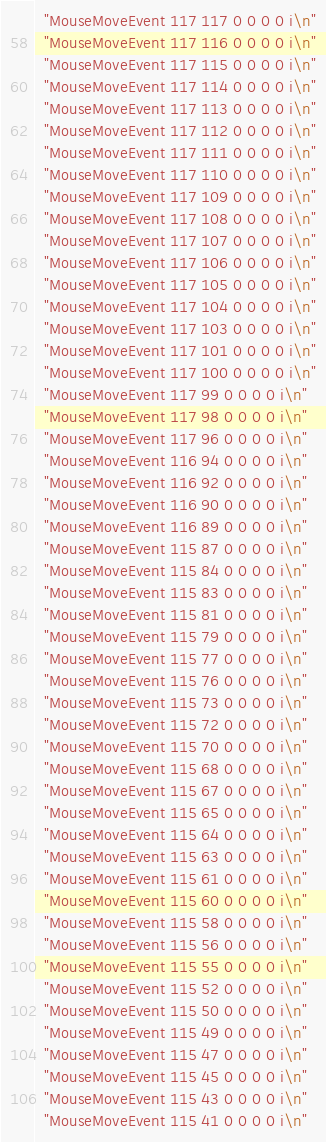<code> <loc_0><loc_0><loc_500><loc_500><_C++_>  "MouseMoveEvent 117 117 0 0 0 0 i\n"
  "MouseMoveEvent 117 116 0 0 0 0 i\n"
  "MouseMoveEvent 117 115 0 0 0 0 i\n"
  "MouseMoveEvent 117 114 0 0 0 0 i\n"
  "MouseMoveEvent 117 113 0 0 0 0 i\n"
  "MouseMoveEvent 117 112 0 0 0 0 i\n"
  "MouseMoveEvent 117 111 0 0 0 0 i\n"
  "MouseMoveEvent 117 110 0 0 0 0 i\n"
  "MouseMoveEvent 117 109 0 0 0 0 i\n"
  "MouseMoveEvent 117 108 0 0 0 0 i\n"
  "MouseMoveEvent 117 107 0 0 0 0 i\n"
  "MouseMoveEvent 117 106 0 0 0 0 i\n"
  "MouseMoveEvent 117 105 0 0 0 0 i\n"
  "MouseMoveEvent 117 104 0 0 0 0 i\n"
  "MouseMoveEvent 117 103 0 0 0 0 i\n"
  "MouseMoveEvent 117 101 0 0 0 0 i\n"
  "MouseMoveEvent 117 100 0 0 0 0 i\n"
  "MouseMoveEvent 117 99 0 0 0 0 i\n"
  "MouseMoveEvent 117 98 0 0 0 0 i\n"
  "MouseMoveEvent 117 96 0 0 0 0 i\n"
  "MouseMoveEvent 116 94 0 0 0 0 i\n"
  "MouseMoveEvent 116 92 0 0 0 0 i\n"
  "MouseMoveEvent 116 90 0 0 0 0 i\n"
  "MouseMoveEvent 116 89 0 0 0 0 i\n"
  "MouseMoveEvent 115 87 0 0 0 0 i\n"
  "MouseMoveEvent 115 84 0 0 0 0 i\n"
  "MouseMoveEvent 115 83 0 0 0 0 i\n"
  "MouseMoveEvent 115 81 0 0 0 0 i\n"
  "MouseMoveEvent 115 79 0 0 0 0 i\n"
  "MouseMoveEvent 115 77 0 0 0 0 i\n"
  "MouseMoveEvent 115 76 0 0 0 0 i\n"
  "MouseMoveEvent 115 73 0 0 0 0 i\n"
  "MouseMoveEvent 115 72 0 0 0 0 i\n"
  "MouseMoveEvent 115 70 0 0 0 0 i\n"
  "MouseMoveEvent 115 68 0 0 0 0 i\n"
  "MouseMoveEvent 115 67 0 0 0 0 i\n"
  "MouseMoveEvent 115 65 0 0 0 0 i\n"
  "MouseMoveEvent 115 64 0 0 0 0 i\n"
  "MouseMoveEvent 115 63 0 0 0 0 i\n"
  "MouseMoveEvent 115 61 0 0 0 0 i\n"
  "MouseMoveEvent 115 60 0 0 0 0 i\n"
  "MouseMoveEvent 115 58 0 0 0 0 i\n"
  "MouseMoveEvent 115 56 0 0 0 0 i\n"
  "MouseMoveEvent 115 55 0 0 0 0 i\n"
  "MouseMoveEvent 115 52 0 0 0 0 i\n"
  "MouseMoveEvent 115 50 0 0 0 0 i\n"
  "MouseMoveEvent 115 49 0 0 0 0 i\n"
  "MouseMoveEvent 115 47 0 0 0 0 i\n"
  "MouseMoveEvent 115 45 0 0 0 0 i\n"
  "MouseMoveEvent 115 43 0 0 0 0 i\n"
  "MouseMoveEvent 115 41 0 0 0 0 i\n"</code> 